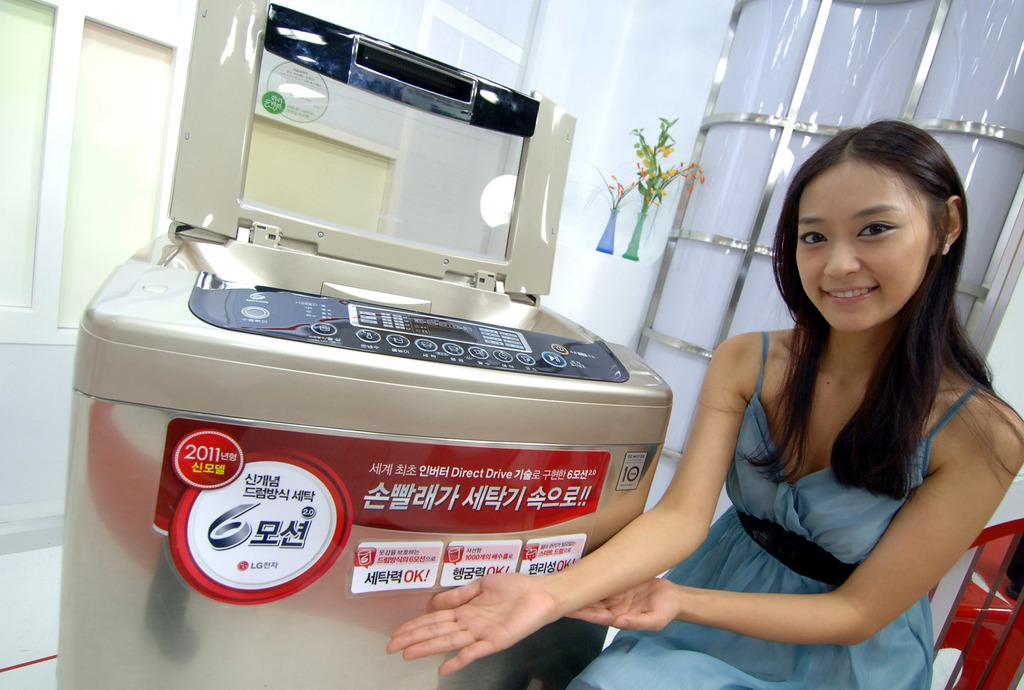<image>
Describe the image concisely. A young woman sits next to a 2011 LG printing machine. 